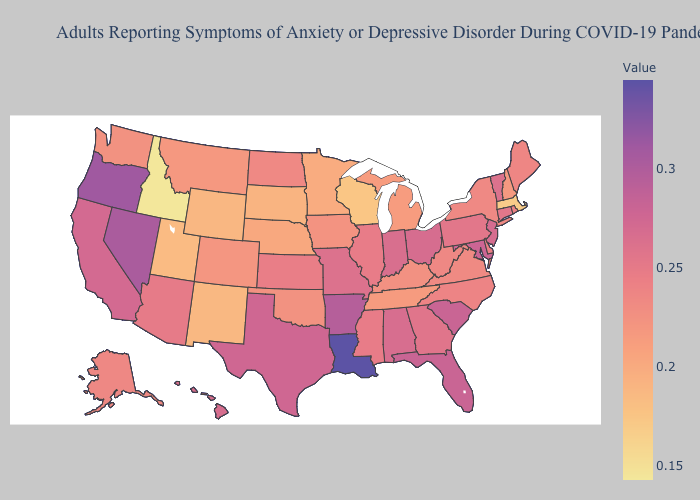Does Massachusetts have the lowest value in the Northeast?
Be succinct. Yes. Which states have the lowest value in the USA?
Keep it brief. Idaho. Which states have the highest value in the USA?
Answer briefly. Louisiana. Does Washington have the highest value in the West?
Concise answer only. No. Among the states that border Tennessee , which have the highest value?
Keep it brief. Arkansas. Among the states that border Missouri , which have the highest value?
Keep it brief. Arkansas. Does Connecticut have the lowest value in the USA?
Concise answer only. No. 